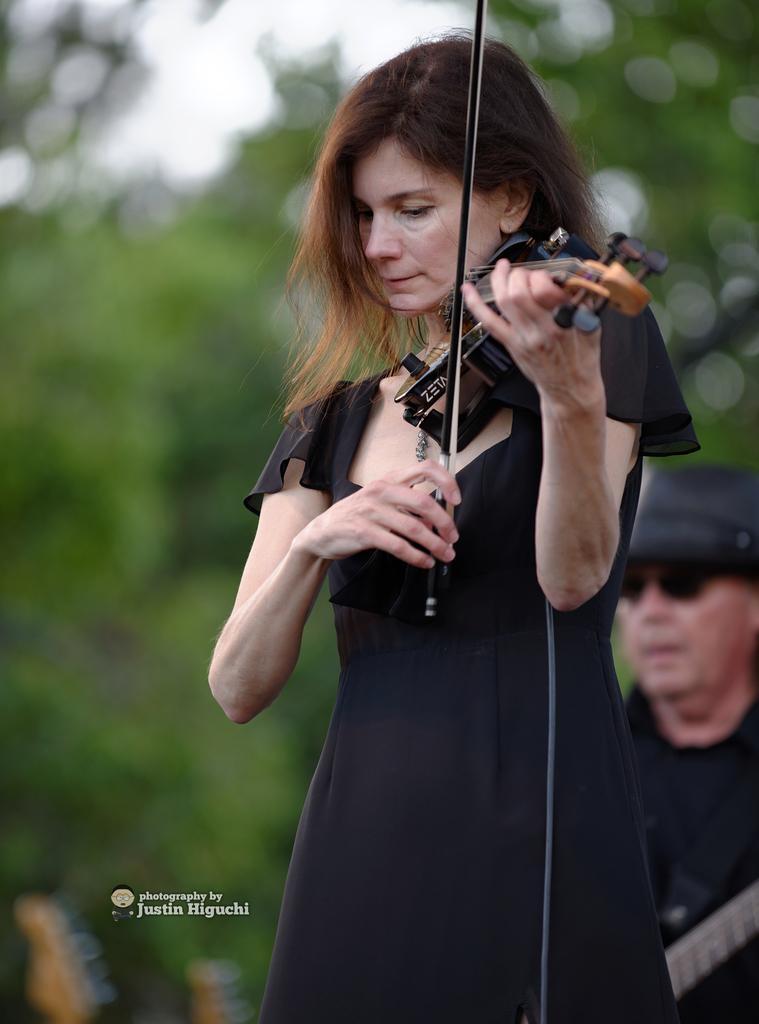Describe this image in one or two sentences. In this image I see a woman who is holding an musical instrument. In the background I see the man and the trees, which are blurred. 